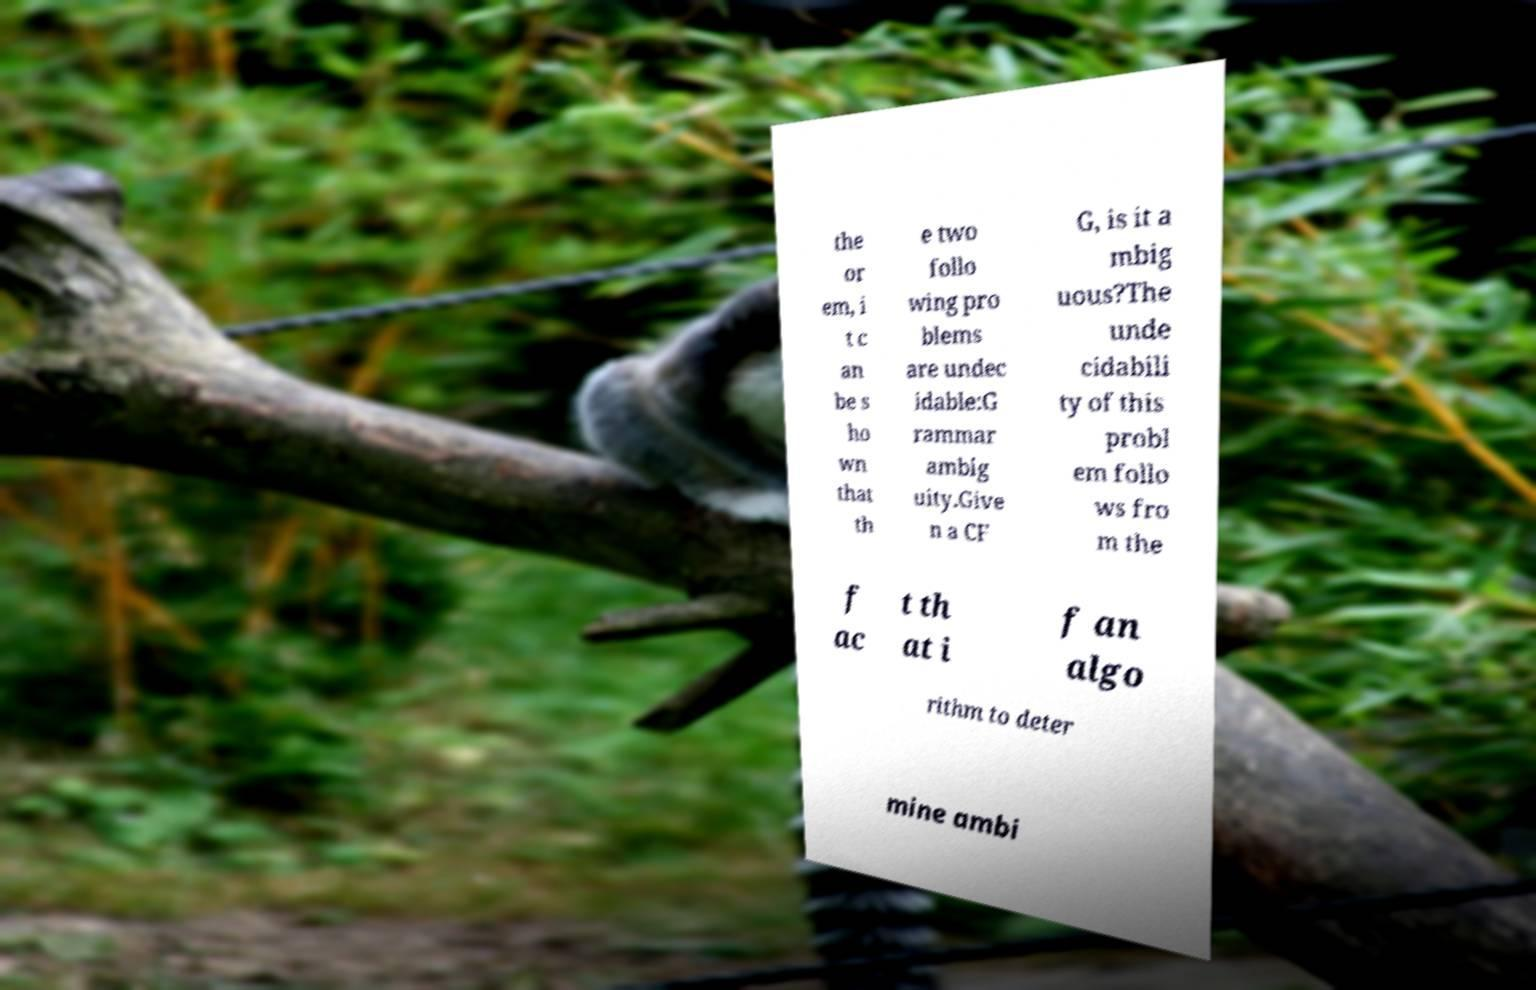I need the written content from this picture converted into text. Can you do that? the or em, i t c an be s ho wn that th e two follo wing pro blems are undec idable:G rammar ambig uity.Give n a CF G, is it a mbig uous?The unde cidabili ty of this probl em follo ws fro m the f ac t th at i f an algo rithm to deter mine ambi 